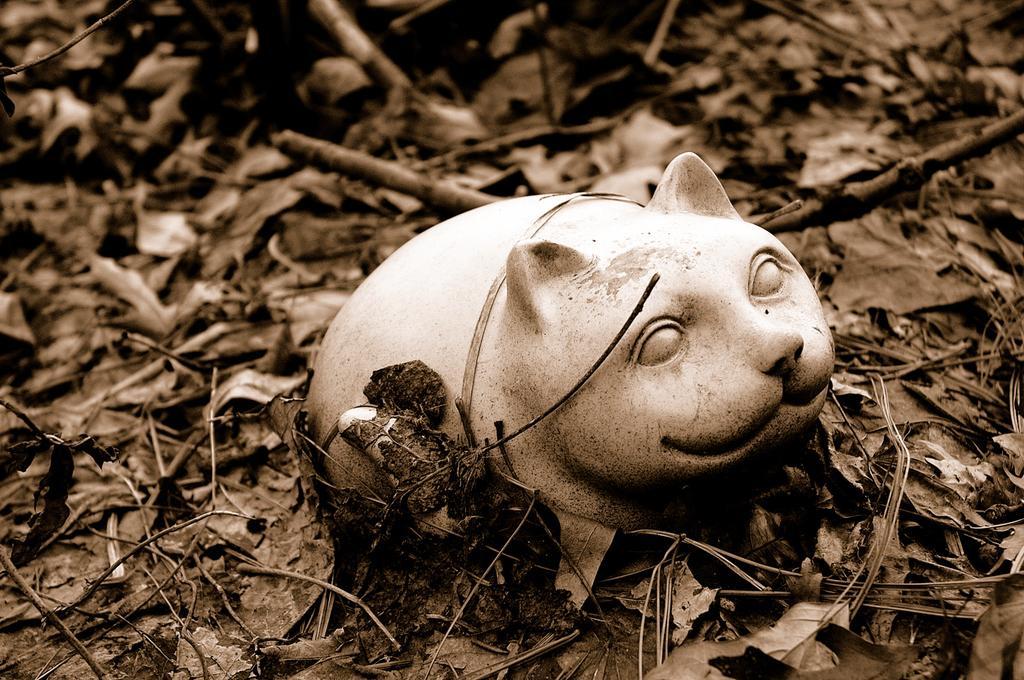What object is present in the image? There is a toy in the image. What is the toy placed on? The toy is on dried leaves. Where is the mailbox located in the image? There is no mailbox present in the image. What type of iron is visible in the image? There is no iron present in the image. 